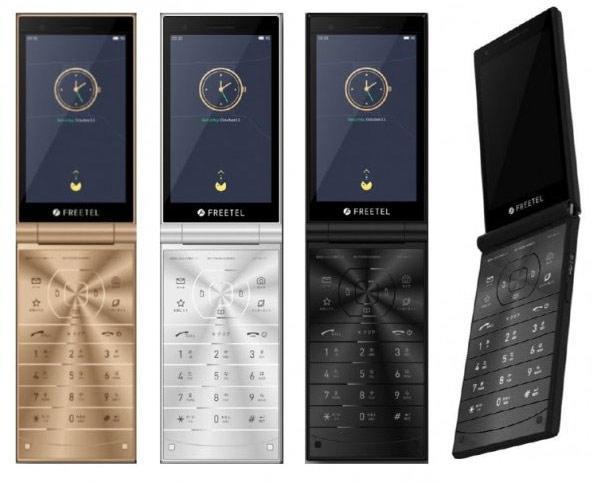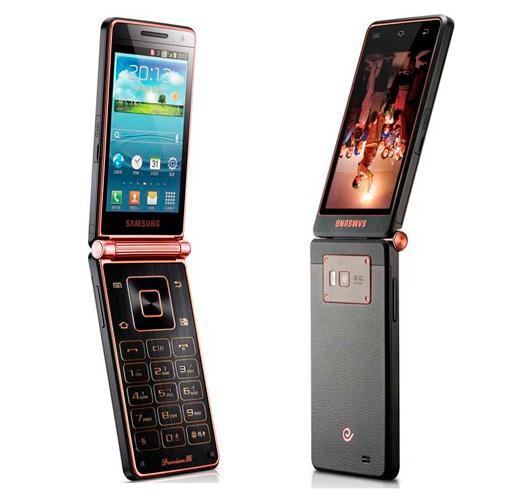The first image is the image on the left, the second image is the image on the right. Considering the images on both sides, is "There is a total of six flip phones." valid? Answer yes or no. Yes. 